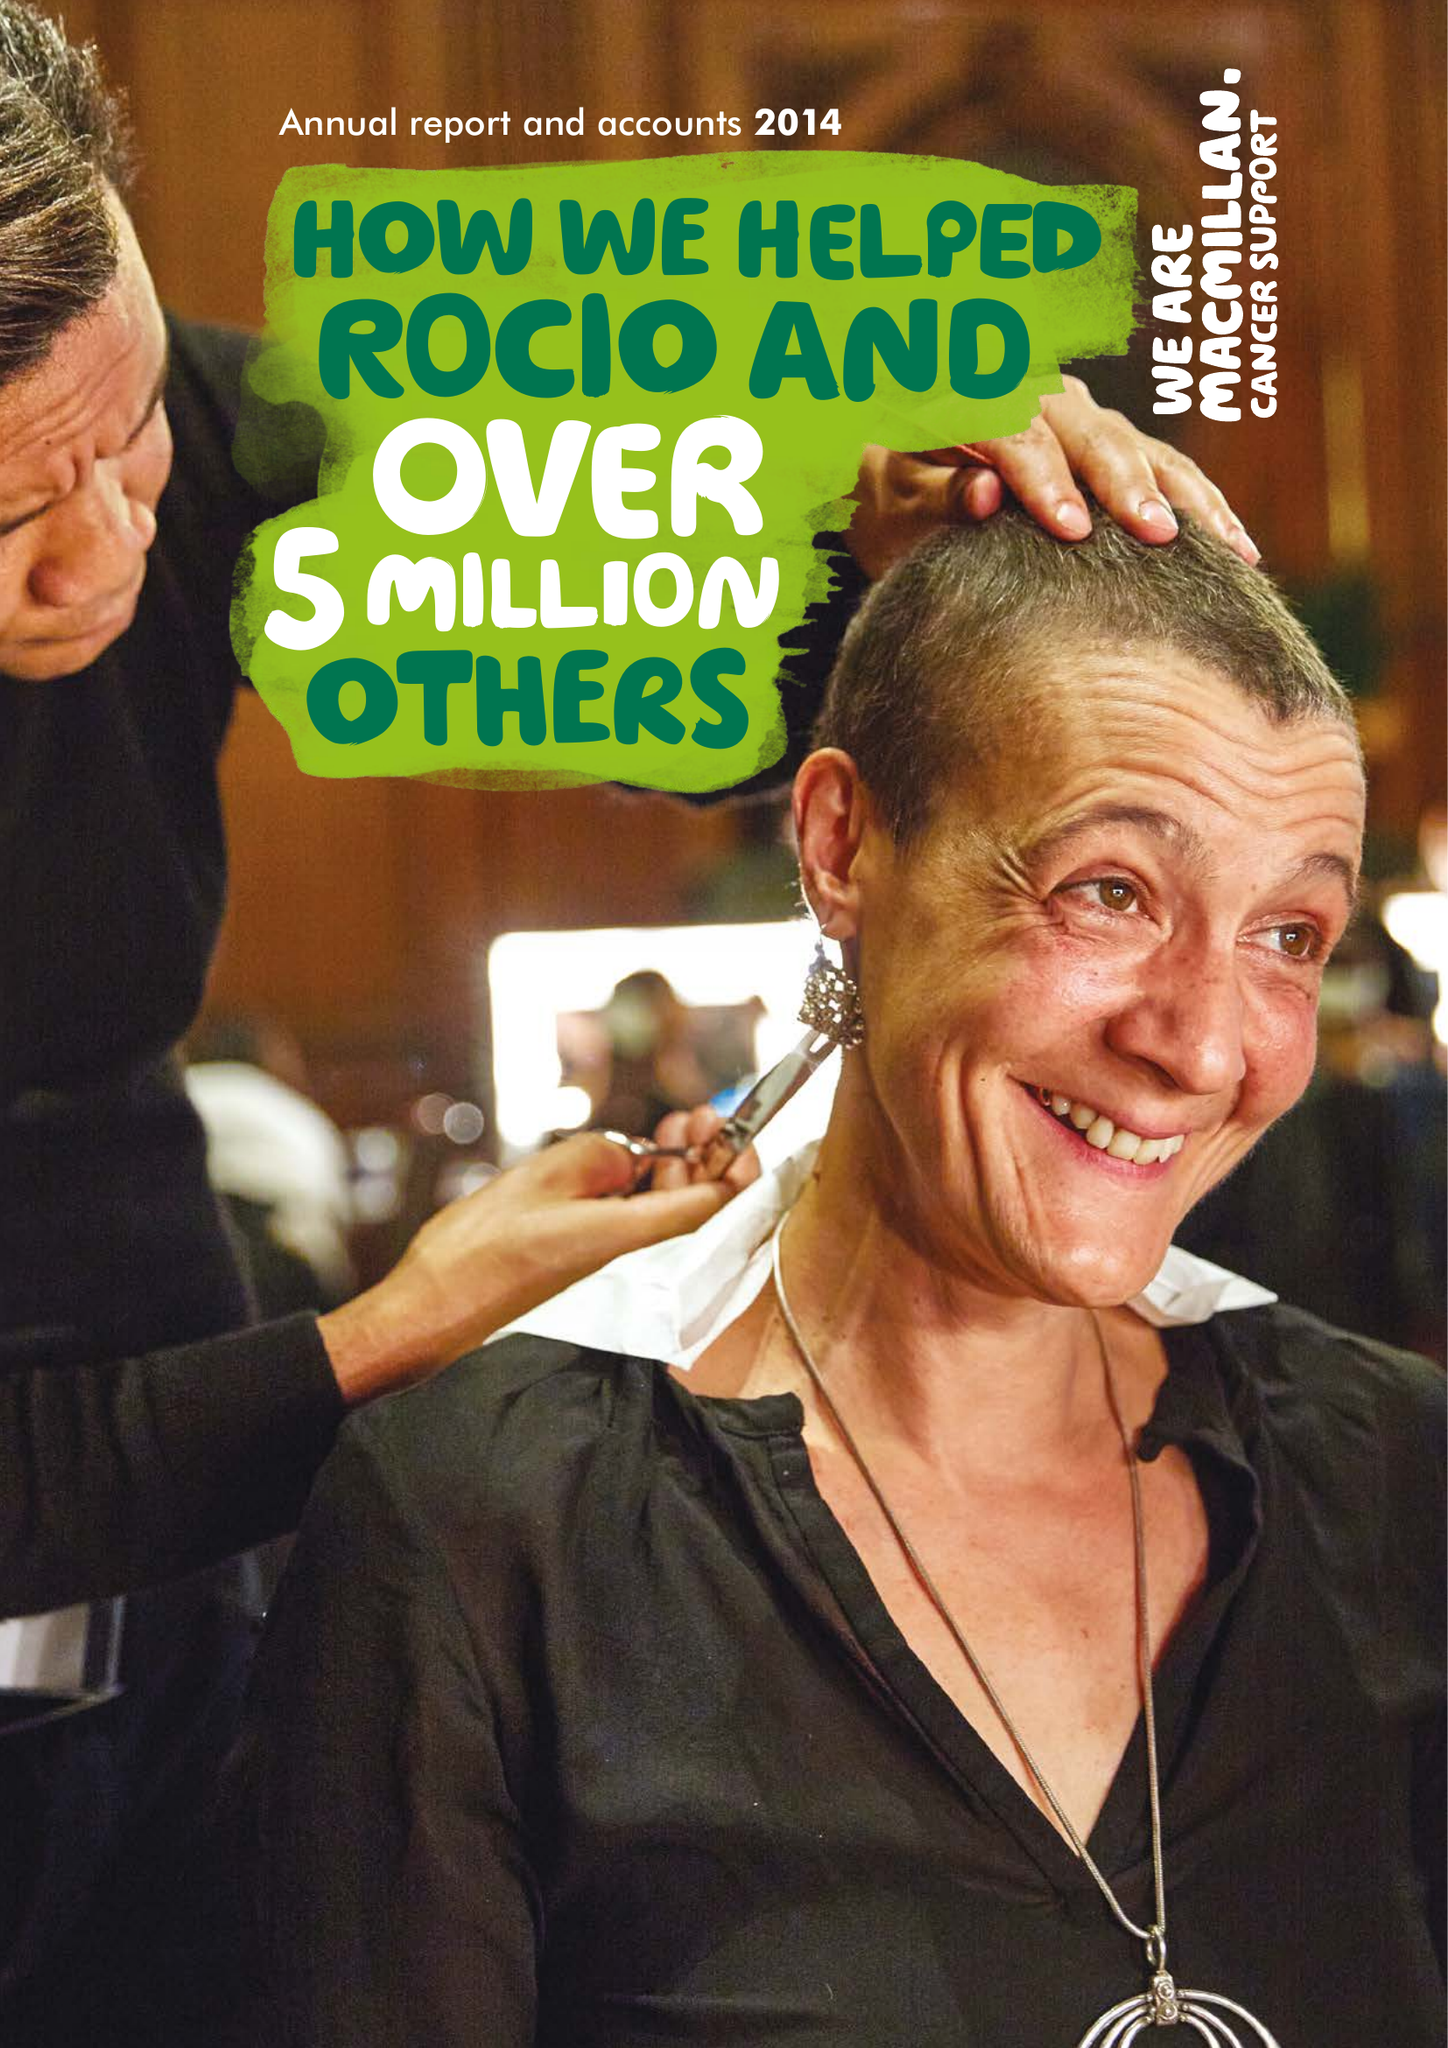What is the value for the charity_number?
Answer the question using a single word or phrase. 261017 